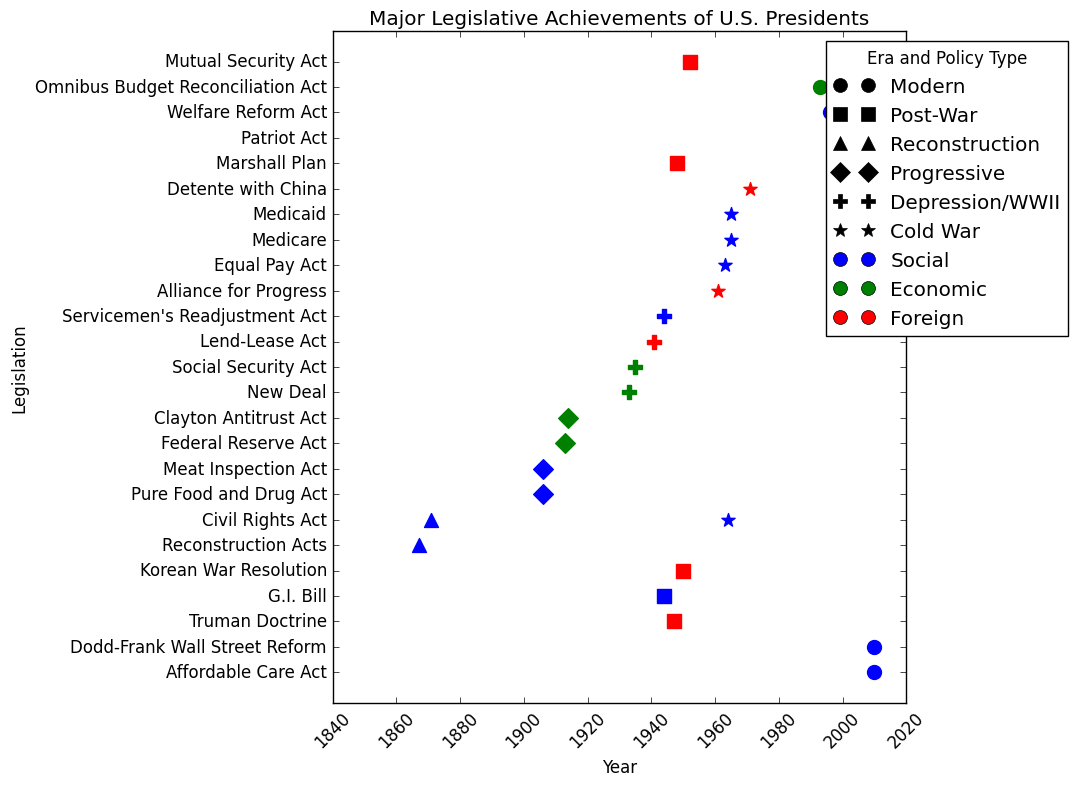Which president has the most legislation achievements displayed on the plot? Count the number of scatter points associated with each president to see who has the most.
Answer: Harry S. Truman Which eras have the largest and smallest number of legislative achievements displayed? Count the number of scatter points for each era and compare them.
Answer: Post-War (largest), Reconstruction (smallest) What type of policy is most prevalent during the Cold War era according to the plot? Look for the frequency of each color (policy type) marker that appears in the Cold War era.
Answer: Social How many pieces of economic legislation are present for the Progressive era? Count the number of green-colored scatter markers within the Progressive era.
Answer: Two Which eras have legislation mainly focused on social policy? Determine which eras have a majority of blue-colored scatter markers.
Answer: Reconstruction, Progressive, Cold War Compare the number of foreign policy achievements between the Post-War and Modern eras. Count the number of red-colored scatter markers in the Post-War and Modern eras and compare the totals.
Answer: Post-War has more foreign policy achievements than Modern How does the number of social legislations during the Cold War era compare to those in the Modern era? Count the blue-colored scatter markers in both the Cold War and Modern eras and compare the totals.
Answer: Cold War has more social legislations What is the earliest year shown for any legislation on the plot? Identify the scatter marker with the smallest year value.
Answer: 1867 Which policy type has the most legislative achievements overall on the plot? Count the scatter markers based on color and identify the most frequent color.
Answer: Social Which era has the most diverse types of policy achievements? Identify the era with the most varied colors (policy types).
Answer: Post-War 